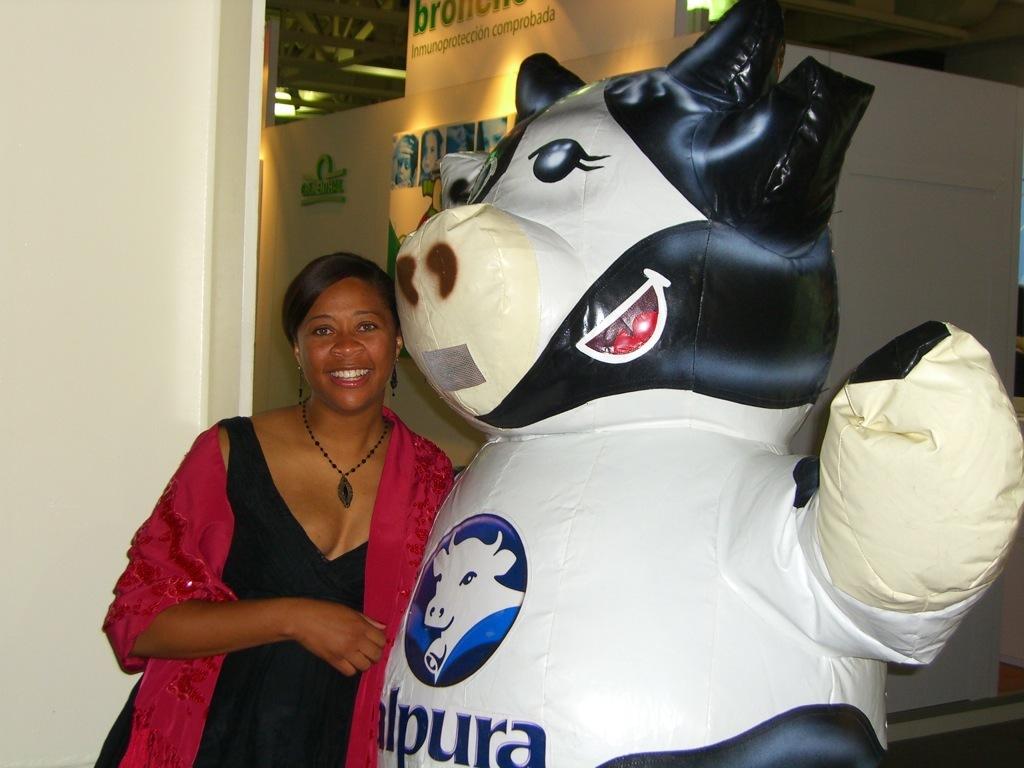How many 'p' do you see?
Offer a very short reply. 1. What is written on the inflatable cow?
Ensure brevity in your answer.  Alpura. 